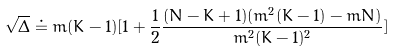<formula> <loc_0><loc_0><loc_500><loc_500>\sqrt { \Delta } \doteq m ( K - 1 ) [ 1 + \frac { 1 } { 2 } \frac { ( N - K + 1 ) ( m ^ { 2 } ( K - 1 ) - m N ) } { m ^ { 2 } ( K - 1 ) ^ { 2 } } ]</formula> 